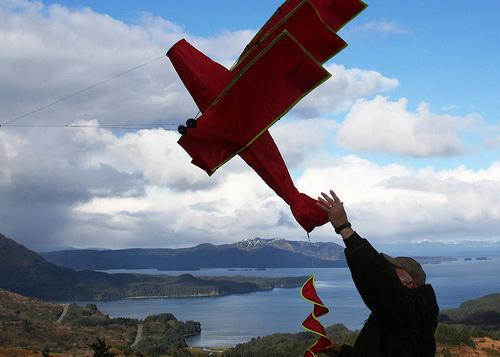Create a vivid description of the man's appearance, actions, and the environment he is in. Surrounded by the serene beauty of a tranquil lakeside and captivating mountain backdrop, under an alluring canvas of clear blue skies and soft, white clouds, a man dons a dark, snug jacket, a fitted baseball cap, and stylish wristwatch as he expertly flies a charming, red airplane-shaped kite with utter delight. Point out the main character's attire and accessories, and describe the object he's holding. The man is wearing a dark jacket, baseball cap, and has a wristwatch on his left hand. He is holding a red airplane-shaped kite with a tail. Mention the key elements found in the image and provide a brief description of the scene. A man holding a kite, wearing a hat and watch, stands by a calm lake surrounded by majestic mountains and clear blue skies with fluffy white clouds. Mention the geographical features and atmospheric conditions captured in the image. The image displays a calm lake, majestic mountains, clear blue sky, and fluffy white clouds, with a man flying a kite. Describe the image in terms of the man's activity, attire, and surroundings. A man dressed in a black jacket and baseball cap is seen flying a red airplane-shaped kite. He stands near a calm lake with majestic mountains and a clear blue sky filled with fluffy white clouds. Briefly describe the individual's actions and the main object he is interacting with. The man is holding and releasing a red airplane-shaped kite, standing near a calm lake with mountains and blue skies in the background. Compose a poetic verse inspired by the scenery depicted in the image. Does take his stand, his heart to fill. Narrate a short story that could be taking place in the image. On a peaceful afternoon, a man finally takes a break from his hectic life to fly his red airplane-shaped kite by a calm lake. Surrounded by majestic mountains and under the clear blue skies, he rediscovers an inner peace long forgotten. Describe the landscape present in the image and provide details about the sky. The landscape features a calm lake, majestic mountains in the background, and a clear blue sky with fluffy white clouds. List the accessories and outfit worn by the man as well as the type of kite he is flying. The man has on a black jacket, baseball cap, wristwatch, and is flying a red airplane-shaped kite with a tail. 